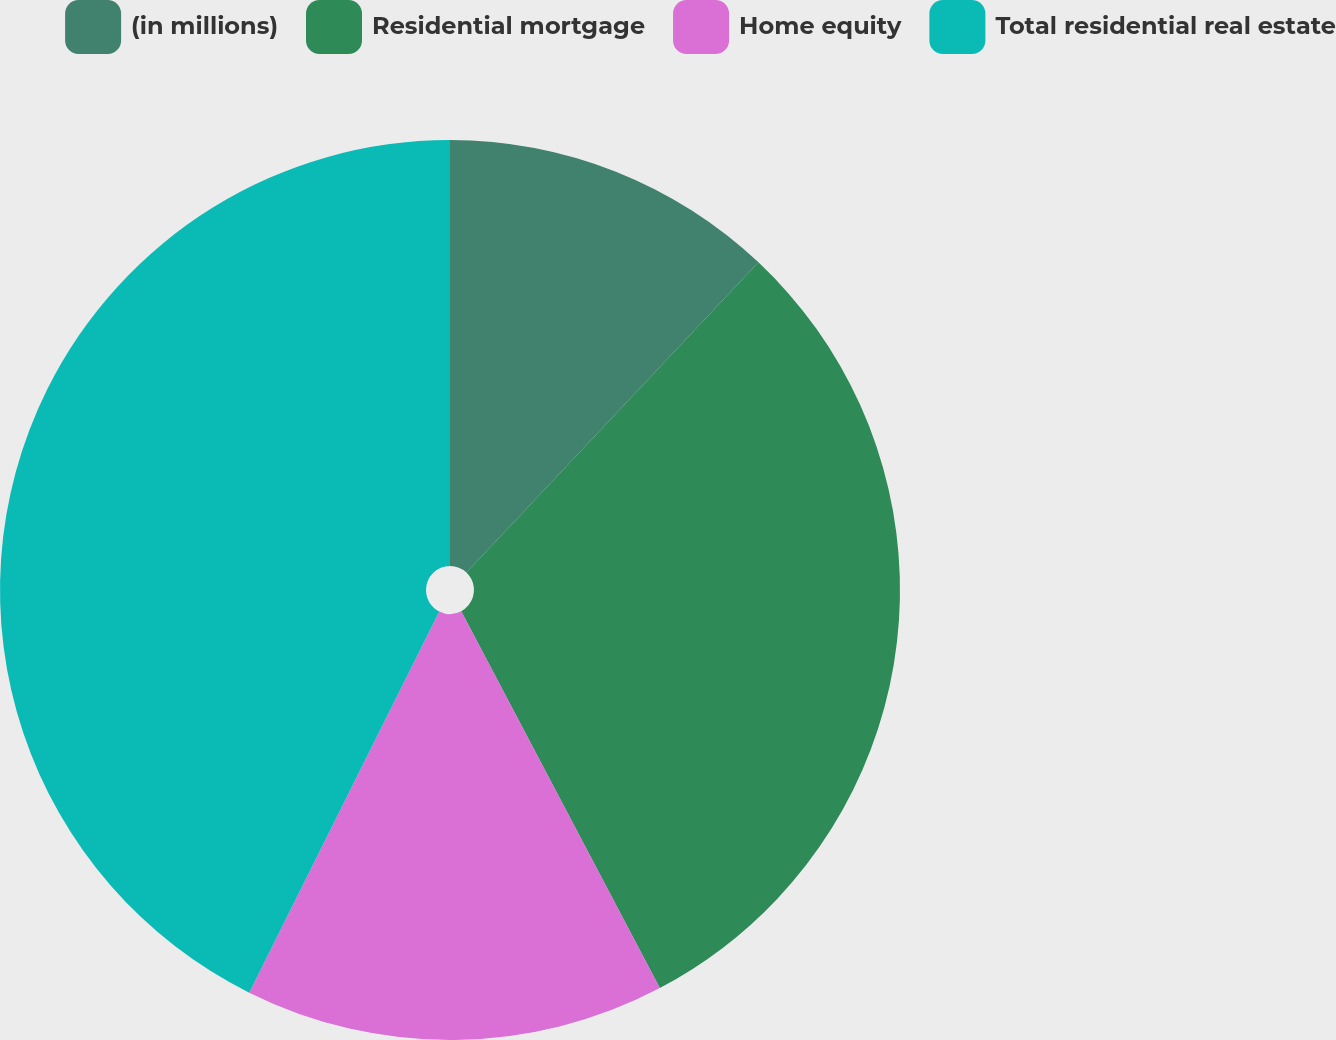Convert chart to OTSL. <chart><loc_0><loc_0><loc_500><loc_500><pie_chart><fcel>(in millions)<fcel>Residential mortgage<fcel>Home equity<fcel>Total residential real estate<nl><fcel>12.02%<fcel>30.26%<fcel>15.08%<fcel>42.64%<nl></chart> 